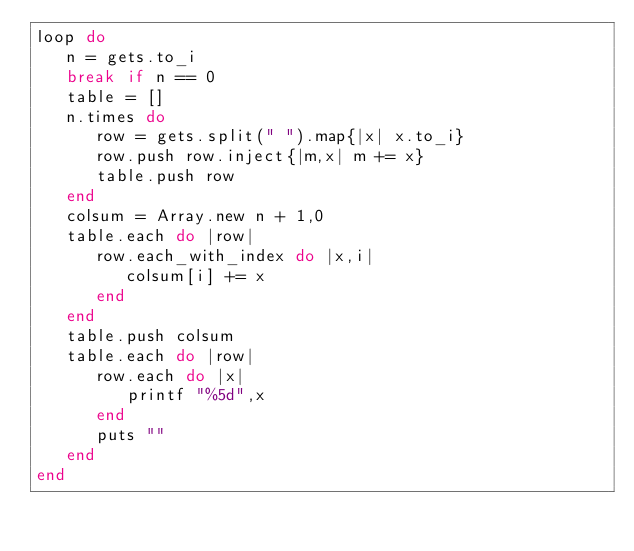<code> <loc_0><loc_0><loc_500><loc_500><_Ruby_>loop do
   n = gets.to_i
   break if n == 0
   table = []
   n.times do
      row = gets.split(" ").map{|x| x.to_i}
      row.push row.inject{|m,x| m += x}
      table.push row
   end
   colsum = Array.new n + 1,0
   table.each do |row|
      row.each_with_index do |x,i|
         colsum[i] += x
      end
   end
   table.push colsum
   table.each do |row|
      row.each do |x|
         printf "%5d",x
      end
      puts ""
   end
end</code> 